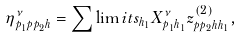Convert formula to latex. <formula><loc_0><loc_0><loc_500><loc_500>\eta _ { p _ { 1 } p p _ { 2 } h } ^ { \nu } = \sum \lim i t s _ { h _ { 1 } } X _ { p _ { 1 } h _ { 1 } } ^ { \nu } z _ { p p _ { 2 } h h _ { 1 } } ^ { ( 2 ) } ,</formula> 